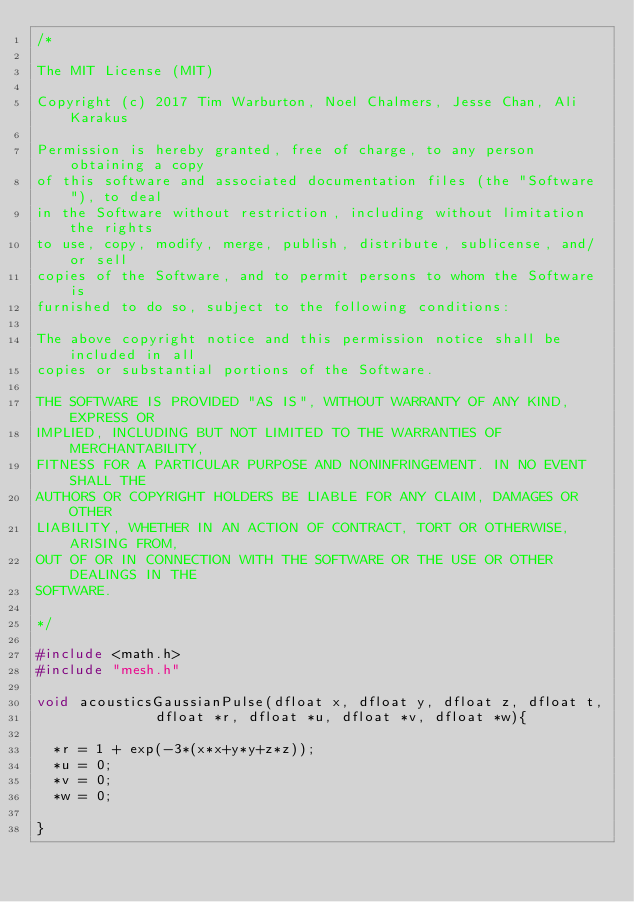<code> <loc_0><loc_0><loc_500><loc_500><_C_>/*

The MIT License (MIT)

Copyright (c) 2017 Tim Warburton, Noel Chalmers, Jesse Chan, Ali Karakus

Permission is hereby granted, free of charge, to any person obtaining a copy
of this software and associated documentation files (the "Software"), to deal
in the Software without restriction, including without limitation the rights
to use, copy, modify, merge, publish, distribute, sublicense, and/or sell
copies of the Software, and to permit persons to whom the Software is
furnished to do so, subject to the following conditions:

The above copyright notice and this permission notice shall be included in all
copies or substantial portions of the Software.

THE SOFTWARE IS PROVIDED "AS IS", WITHOUT WARRANTY OF ANY KIND, EXPRESS OR
IMPLIED, INCLUDING BUT NOT LIMITED TO THE WARRANTIES OF MERCHANTABILITY,
FITNESS FOR A PARTICULAR PURPOSE AND NONINFRINGEMENT. IN NO EVENT SHALL THE
AUTHORS OR COPYRIGHT HOLDERS BE LIABLE FOR ANY CLAIM, DAMAGES OR OTHER
LIABILITY, WHETHER IN AN ACTION OF CONTRACT, TORT OR OTHERWISE, ARISING FROM,
OUT OF OR IN CONNECTION WITH THE SOFTWARE OR THE USE OR OTHER DEALINGS IN THE
SOFTWARE.

*/

#include <math.h>
#include "mesh.h"

void acousticsGaussianPulse(dfloat x, dfloat y, dfloat z, dfloat t,
		      dfloat *r, dfloat *u, dfloat *v, dfloat *w){

  *r = 1 + exp(-3*(x*x+y*y+z*z));
  *u = 0;
  *v = 0;
  *w = 0;

}
</code> 